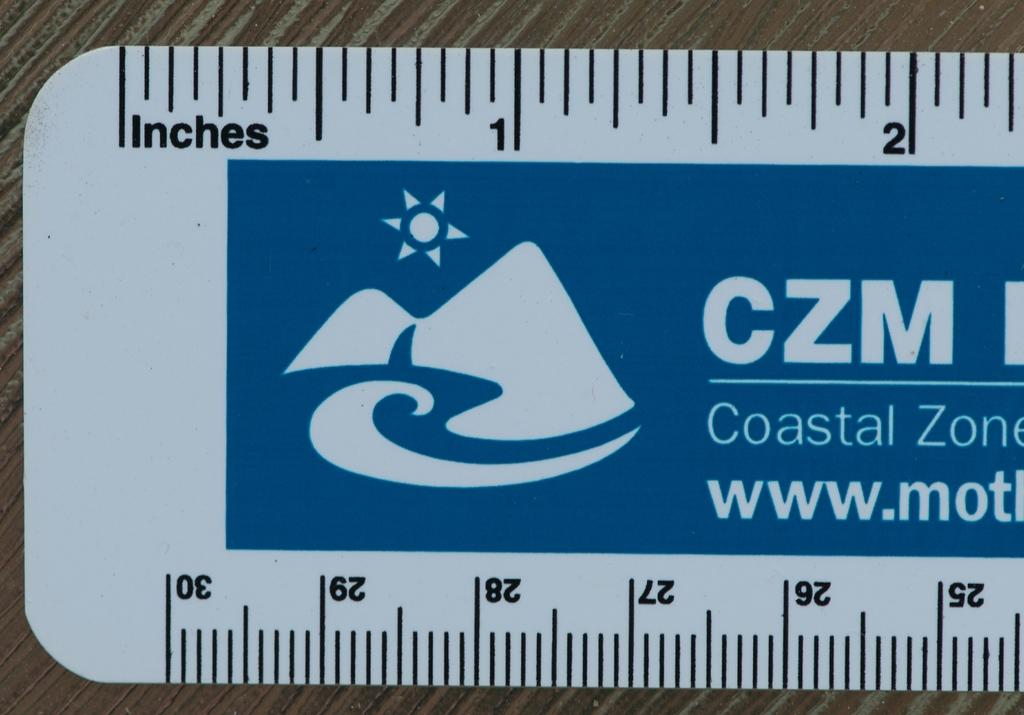<image>
Offer a succinct explanation of the picture presented. A blue and white CZM ruler on a table. 